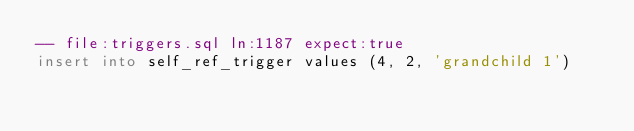Convert code to text. <code><loc_0><loc_0><loc_500><loc_500><_SQL_>-- file:triggers.sql ln:1187 expect:true
insert into self_ref_trigger values (4, 2, 'grandchild 1')
</code> 